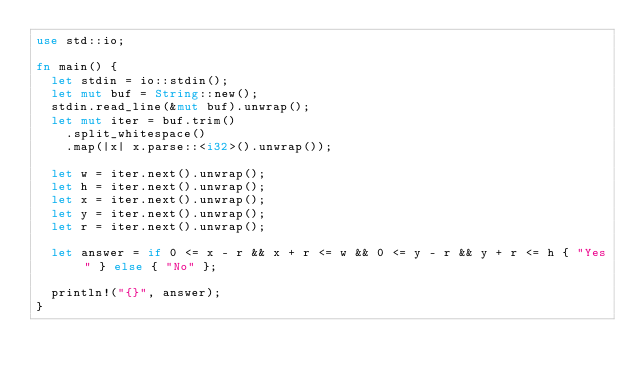<code> <loc_0><loc_0><loc_500><loc_500><_Rust_>use std::io;

fn main() {
  let stdin = io::stdin();
  let mut buf = String::new();
  stdin.read_line(&mut buf).unwrap();
  let mut iter = buf.trim()
    .split_whitespace()
    .map(|x| x.parse::<i32>().unwrap());

  let w = iter.next().unwrap();
  let h = iter.next().unwrap();
  let x = iter.next().unwrap();
  let y = iter.next().unwrap();
  let r = iter.next().unwrap();

  let answer = if 0 <= x - r && x + r <= w && 0 <= y - r && y + r <= h { "Yes" } else { "No" };

  println!("{}", answer);
}
</code> 